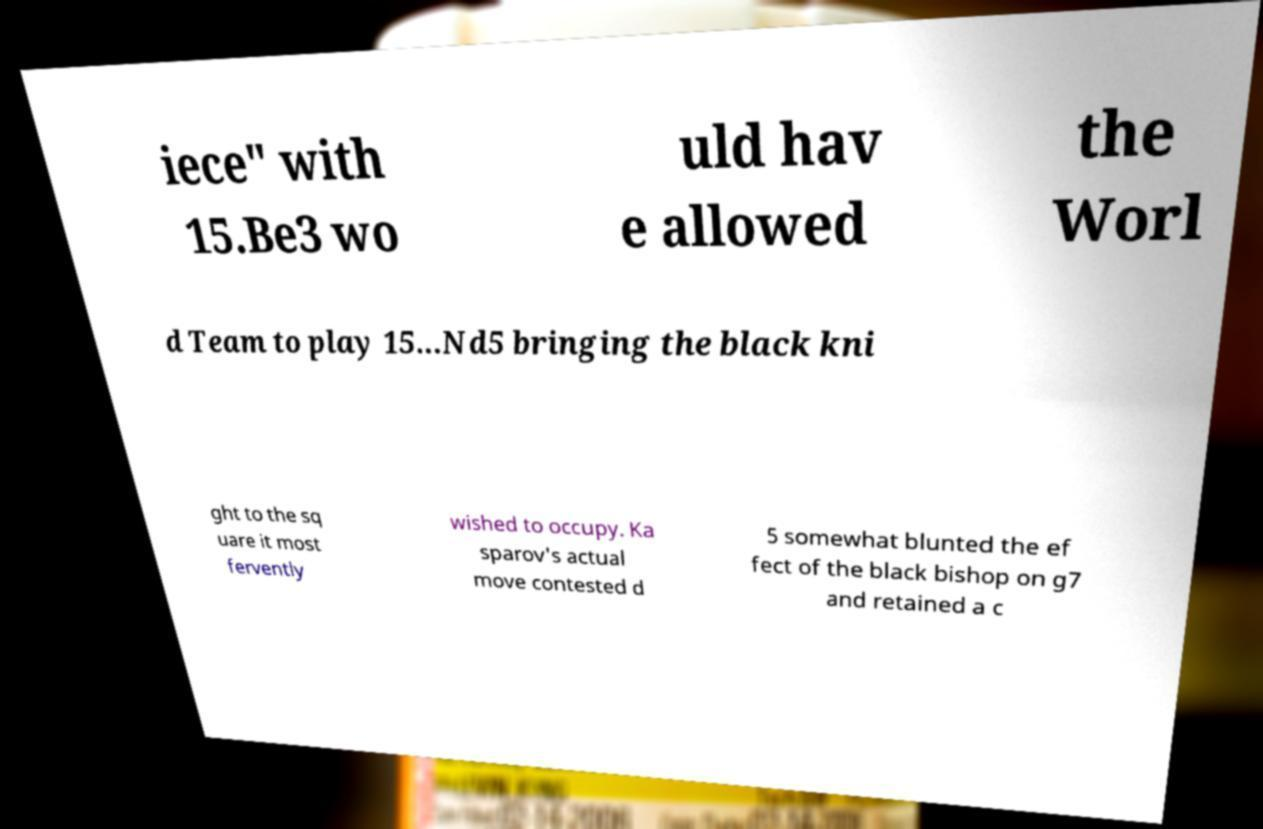For documentation purposes, I need the text within this image transcribed. Could you provide that? iece" with 15.Be3 wo uld hav e allowed the Worl d Team to play 15...Nd5 bringing the black kni ght to the sq uare it most fervently wished to occupy. Ka sparov's actual move contested d 5 somewhat blunted the ef fect of the black bishop on g7 and retained a c 